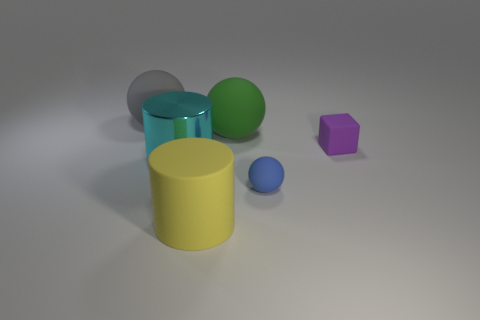Add 1 tiny green metallic blocks. How many objects exist? 7 Subtract all cylinders. How many objects are left? 4 Add 4 big gray things. How many big gray things are left? 5 Add 6 small blue balls. How many small blue balls exist? 7 Subtract 1 blue balls. How many objects are left? 5 Subtract all big gray matte objects. Subtract all big gray objects. How many objects are left? 4 